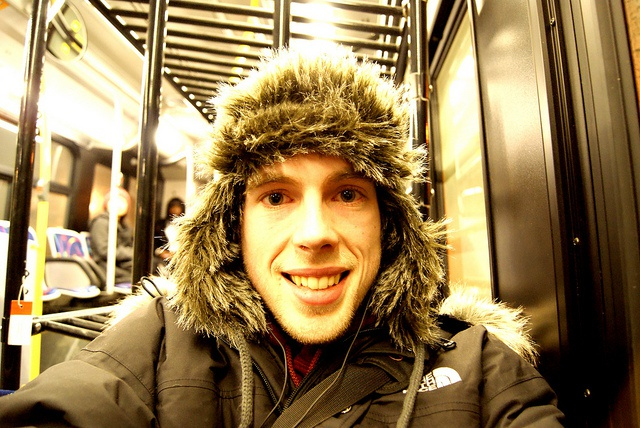Describe the objects in this image and their specific colors. I can see people in orange, black, olive, and maroon tones, people in orange, ivory, tan, and olive tones, and people in orange, black, ivory, and maroon tones in this image. 